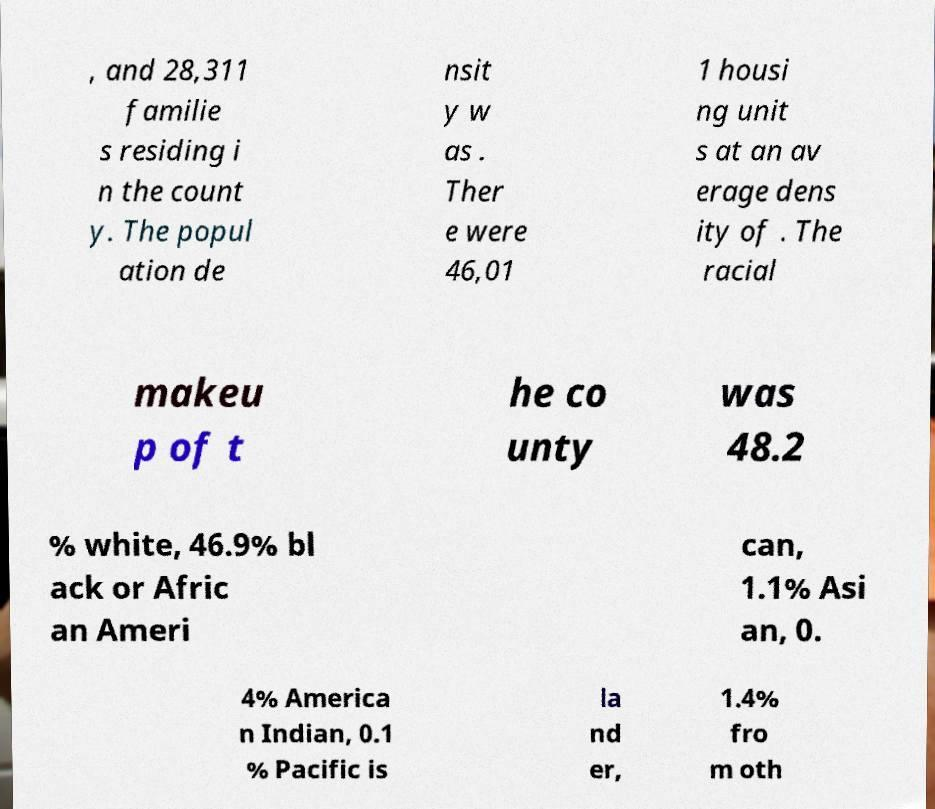Please identify and transcribe the text found in this image. , and 28,311 familie s residing i n the count y. The popul ation de nsit y w as . Ther e were 46,01 1 housi ng unit s at an av erage dens ity of . The racial makeu p of t he co unty was 48.2 % white, 46.9% bl ack or Afric an Ameri can, 1.1% Asi an, 0. 4% America n Indian, 0.1 % Pacific is la nd er, 1.4% fro m oth 